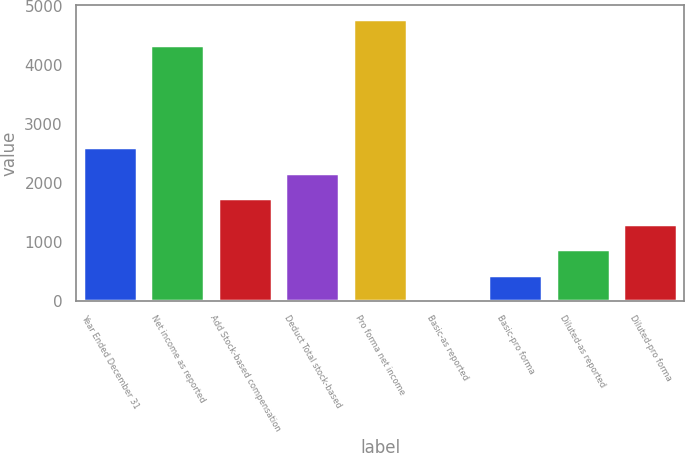Convert chart to OTSL. <chart><loc_0><loc_0><loc_500><loc_500><bar_chart><fcel>Year Ended December 31<fcel>Net income as reported<fcel>Add Stock-based compensation<fcel>Deduct Total stock-based<fcel>Pro forma net income<fcel>Basic-as reported<fcel>Basic-pro forma<fcel>Diluted-as reported<fcel>Diluted-pro forma<nl><fcel>2608.89<fcel>4347<fcel>1739.85<fcel>2174.37<fcel>4781.52<fcel>1.77<fcel>436.29<fcel>870.81<fcel>1305.33<nl></chart> 